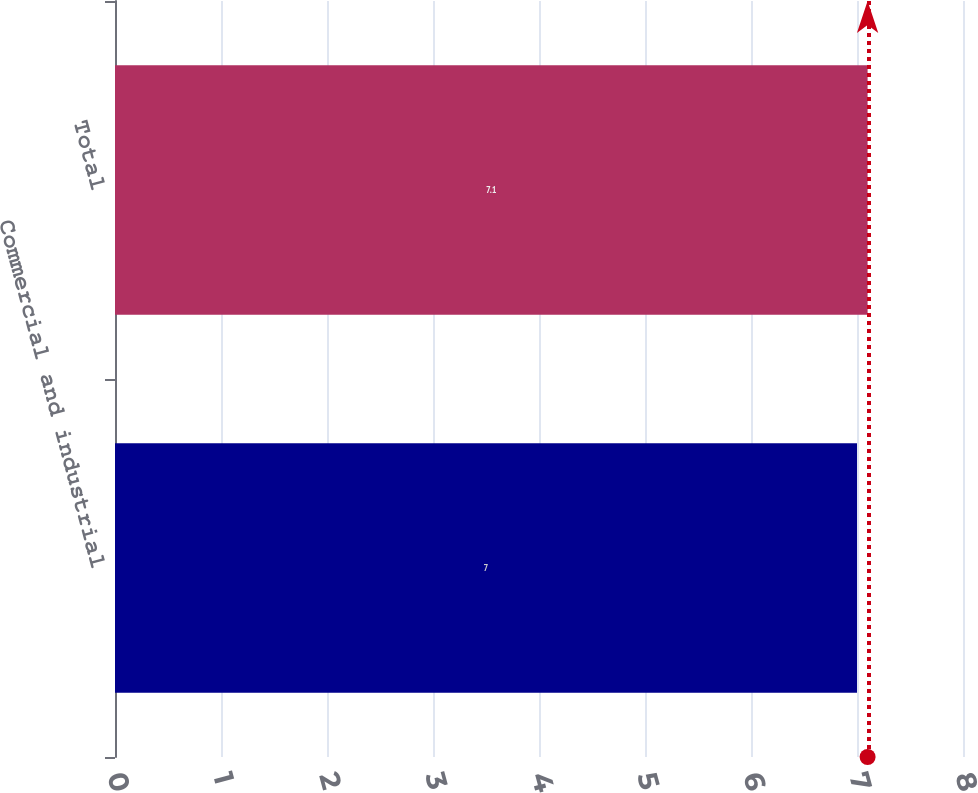Convert chart to OTSL. <chart><loc_0><loc_0><loc_500><loc_500><bar_chart><fcel>Commercial and industrial<fcel>Total<nl><fcel>7<fcel>7.1<nl></chart> 